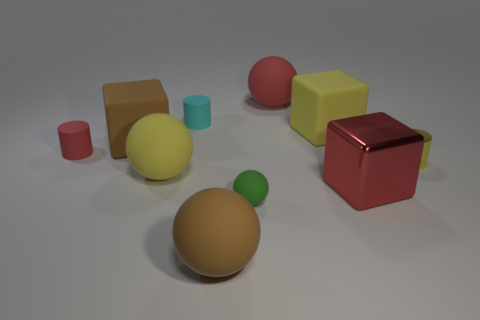Subtract all big brown matte spheres. How many spheres are left? 3 Subtract all red spheres. How many spheres are left? 3 Subtract 3 spheres. How many spheres are left? 1 Subtract all gray balls. Subtract all red cylinders. How many balls are left? 4 Subtract all brown matte balls. Subtract all yellow things. How many objects are left? 6 Add 3 tiny red matte things. How many tiny red matte things are left? 4 Add 1 gray things. How many gray things exist? 1 Subtract 1 yellow cylinders. How many objects are left? 9 Subtract all blocks. How many objects are left? 7 